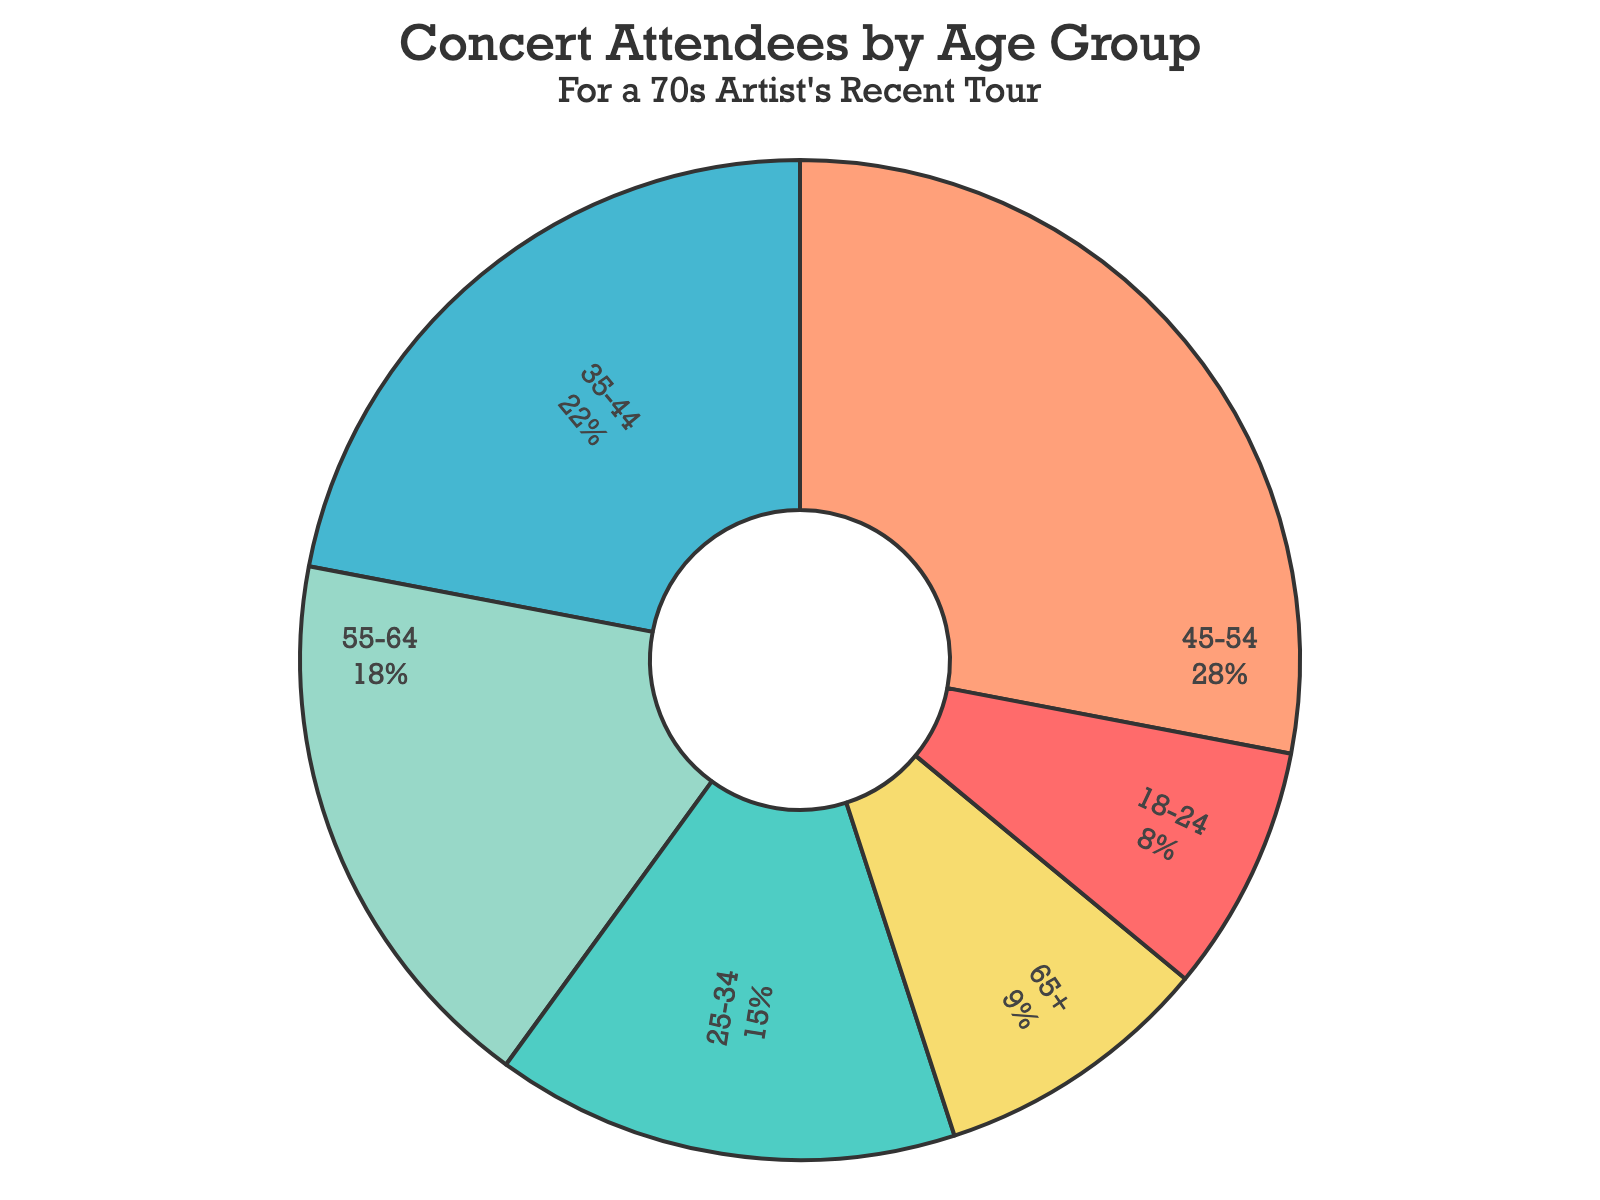What is the largest age group of concert attendees? The pie chart indicates the age groups and their respective percentages. The age group with the highest percentage is 45-54, with 28%.
Answer: 45-54 Which age group has the least representation among concert attendees? The smallest slice on the pie chart represents the 18-24 age group, which has 8% of the total.
Answer: 18-24 How do the combined percentages of the age groups 55-64 and 65+ compare to the 45-54 age group’s percentage? Summing up the percentages for 55-64 (18%) and 65+ (9%) gives 27%, which is 1% less than the 45-54 age group (28%).
Answer: 1% less What is the total percentage of concert attendees aged 35-54? The age groups 35-44 and 45-54 need to be summed. 35-44 is 22% and 45-54 is 28%, thus their total is 22% + 28% = 50%.
Answer: 50% How much more popular is the 45-54 age group compared to the 25-34 age group? Subtract the percentage of 25-34 (15%) from the percentage of 45-54 (28%) to find out. 28% - 15% = 13%.
Answer: 13% Which color represents the 18-24 age group? The pie chart uses distinct colors for different age groups. The 18-24 age group is represented by the red color.
Answer: Red What is the difference in percentage between the age group 35-44 and the combined age group of 18-24 and 25-34? First, sum the percentages for 18-24 (8%) and 25-34 (15%), which gives 23%. Then, find the difference between 35-44 (22%) and 23%. 22% - 23% = -1%.
Answer: -1% How do the percentages of the age groups below 34 years old (18-24 and 25-34) compare to those above 54 years old (55-64 and 65+)? Sum the percentages for 18-24 (8%) and 25-34 (15%) to get 23%. Sum the percentages for 55-64 (18%) and 65+ (9%) to get 27%. Thus, those above 54 are 4% more than those below 34.
Answer: 4% more Which age groups collectively account for more than half of the concert attendees? The age groups are 35-44 (22%) and 45-54 (28%). Their combined percentage is 22% + 28% = 50%. So, these two groups alone account for exactly half of the concert attendees, not more. The group 45-54 alone represents 28%, combining with any one of, for example, 55-64 (18%) will make them collectively account for more than half, but 50% itself is not a majority so it doesn't account for more than half alone. Therefore, it's complicated, and no single two separate age groups collectively represent more than half, but combining specific sets in certain combinations might, but not directly beyond half.
Answer: None 